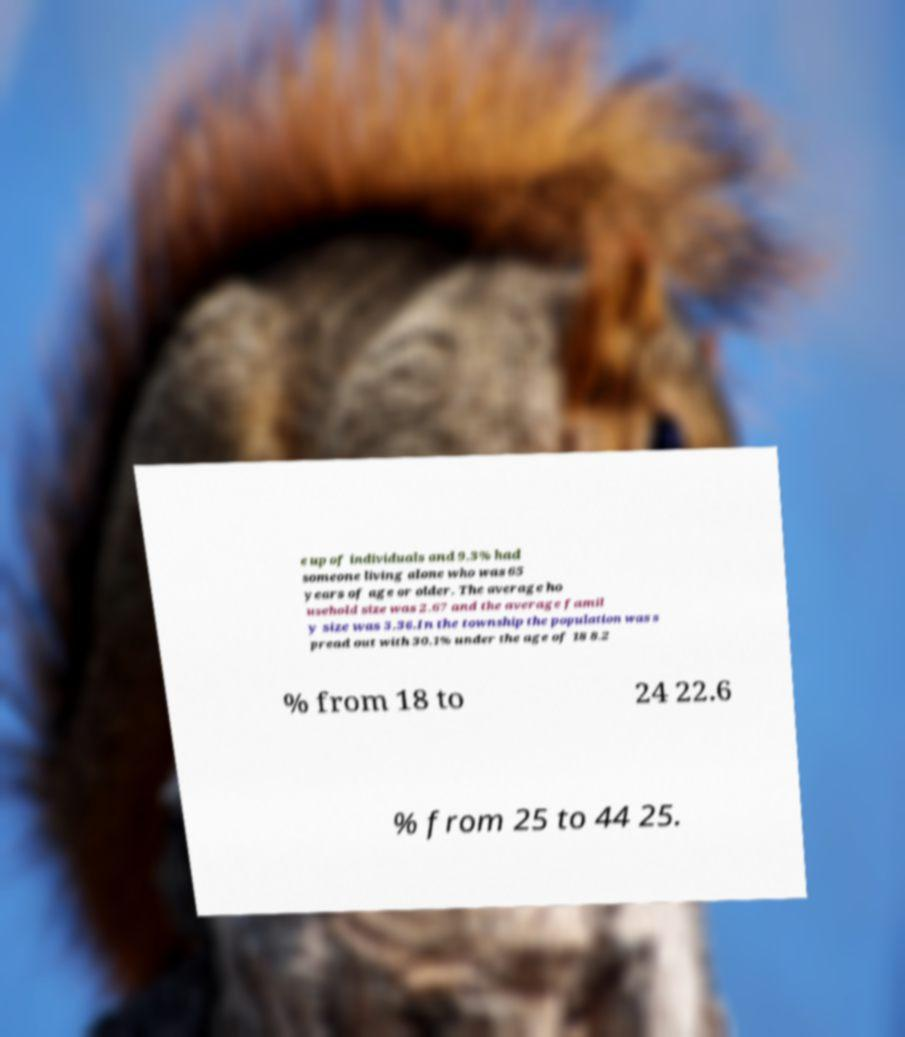Could you extract and type out the text from this image? e up of individuals and 9.3% had someone living alone who was 65 years of age or older. The average ho usehold size was 2.67 and the average famil y size was 3.36.In the township the population was s pread out with 30.1% under the age of 18 8.2 % from 18 to 24 22.6 % from 25 to 44 25. 